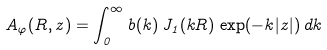<formula> <loc_0><loc_0><loc_500><loc_500>A _ { \varphi } ( R , z ) = \int _ { 0 } ^ { \infty } b ( k ) \, J _ { 1 } ( k R ) \, \exp ( - k | z | ) \, d k</formula> 